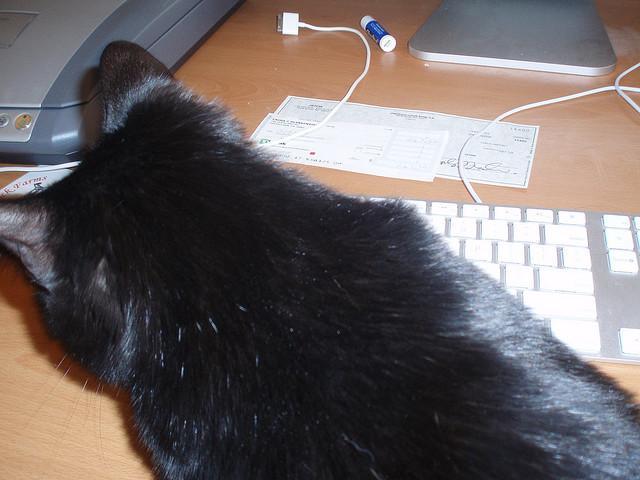How many keyboards can be seen?
Give a very brief answer. 1. 